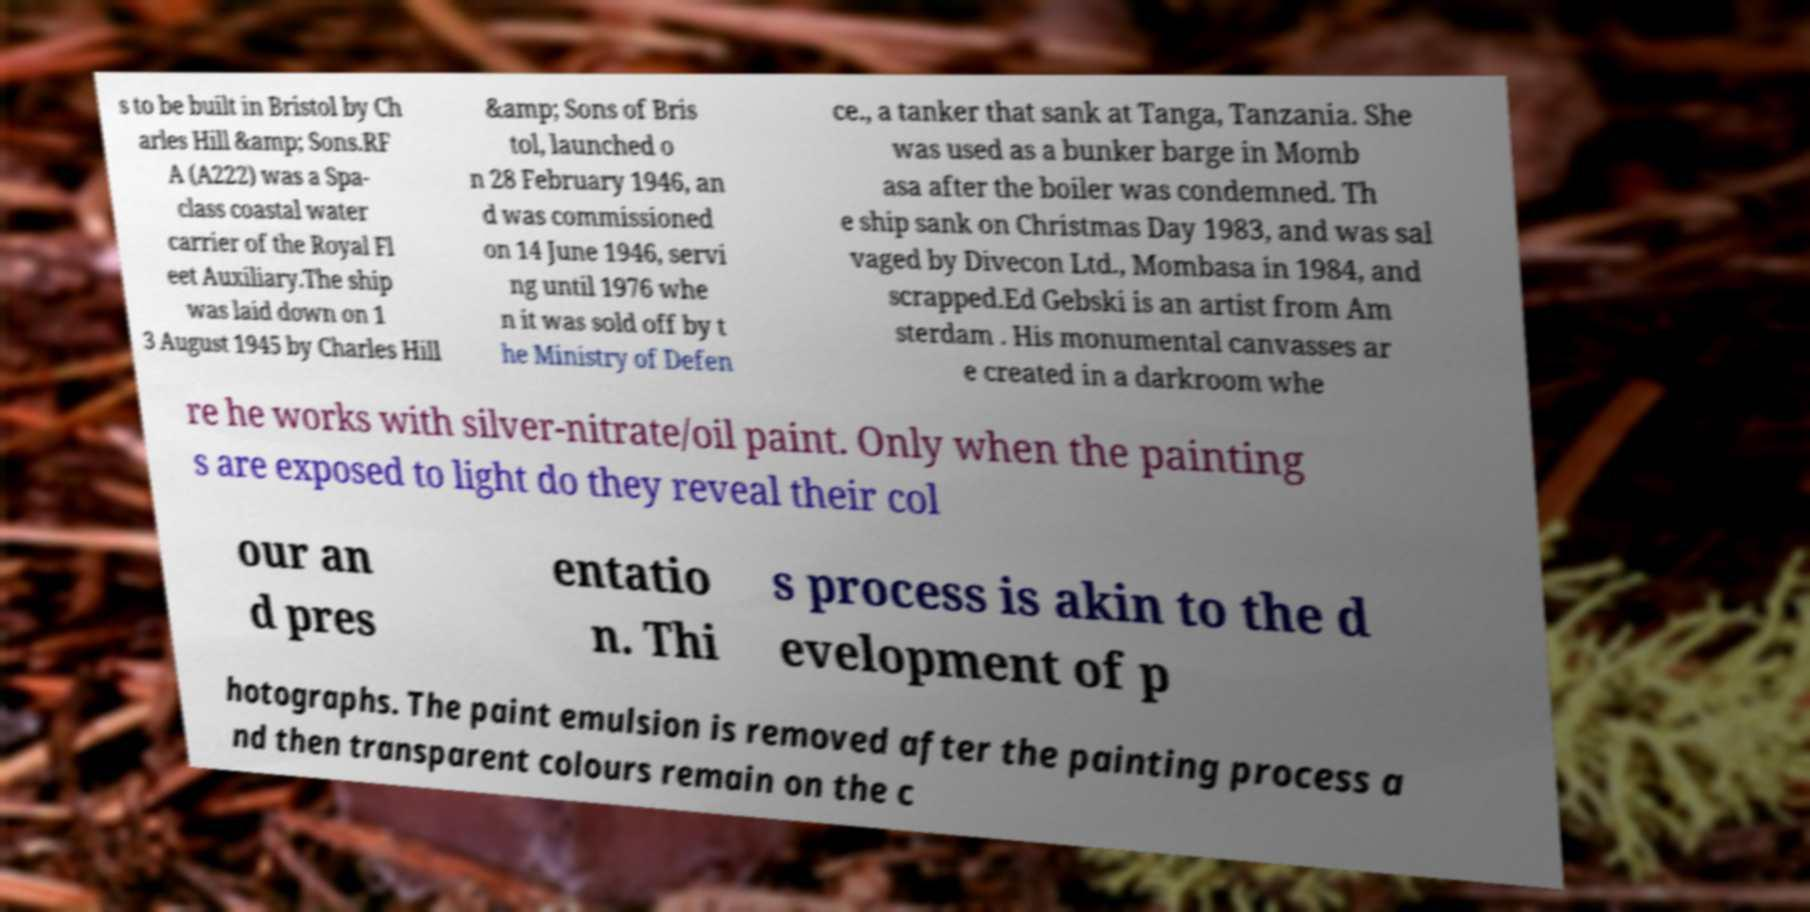What messages or text are displayed in this image? I need them in a readable, typed format. s to be built in Bristol by Ch arles Hill &amp; Sons.RF A (A222) was a Spa- class coastal water carrier of the Royal Fl eet Auxiliary.The ship was laid down on 1 3 August 1945 by Charles Hill &amp; Sons of Bris tol, launched o n 28 February 1946, an d was commissioned on 14 June 1946, servi ng until 1976 whe n it was sold off by t he Ministry of Defen ce., a tanker that sank at Tanga, Tanzania. She was used as a bunker barge in Momb asa after the boiler was condemned. Th e ship sank on Christmas Day 1983, and was sal vaged by Divecon Ltd., Mombasa in 1984, and scrapped.Ed Gebski is an artist from Am sterdam . His monumental canvasses ar e created in a darkroom whe re he works with silver-nitrate/oil paint. Only when the painting s are exposed to light do they reveal their col our an d pres entatio n. Thi s process is akin to the d evelopment of p hotographs. The paint emulsion is removed after the painting process a nd then transparent colours remain on the c 